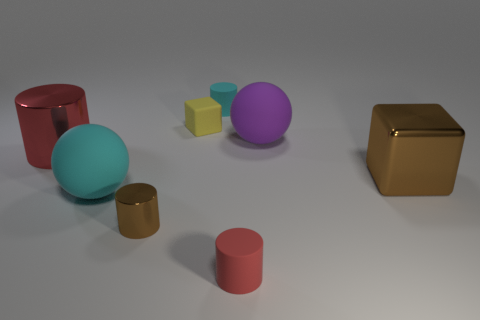Is there a yellow block that has the same size as the red matte object?
Keep it short and to the point. Yes. How big is the matte sphere in front of the large rubber object on the right side of the big cyan matte thing?
Your answer should be very brief. Large. What number of shiny things are the same color as the big shiny block?
Ensure brevity in your answer.  1. There is a red thing that is to the left of the red cylinder that is on the right side of the yellow matte block; what shape is it?
Your response must be concise. Cylinder. What number of yellow objects are made of the same material as the tiny red cylinder?
Provide a short and direct response. 1. What is the material of the object left of the cyan rubber sphere?
Offer a terse response. Metal. There is a shiny object that is right of the big rubber sphere that is to the right of the small cylinder behind the big cyan object; what shape is it?
Your answer should be very brief. Cube. Do the metallic thing right of the tiny brown thing and the metallic cylinder behind the large brown metal cube have the same color?
Your answer should be very brief. No. Is the number of small metal things that are behind the big purple thing less than the number of cyan rubber things that are in front of the tiny cyan rubber cylinder?
Provide a short and direct response. Yes. What color is the tiny metal object that is the same shape as the big red thing?
Keep it short and to the point. Brown. 